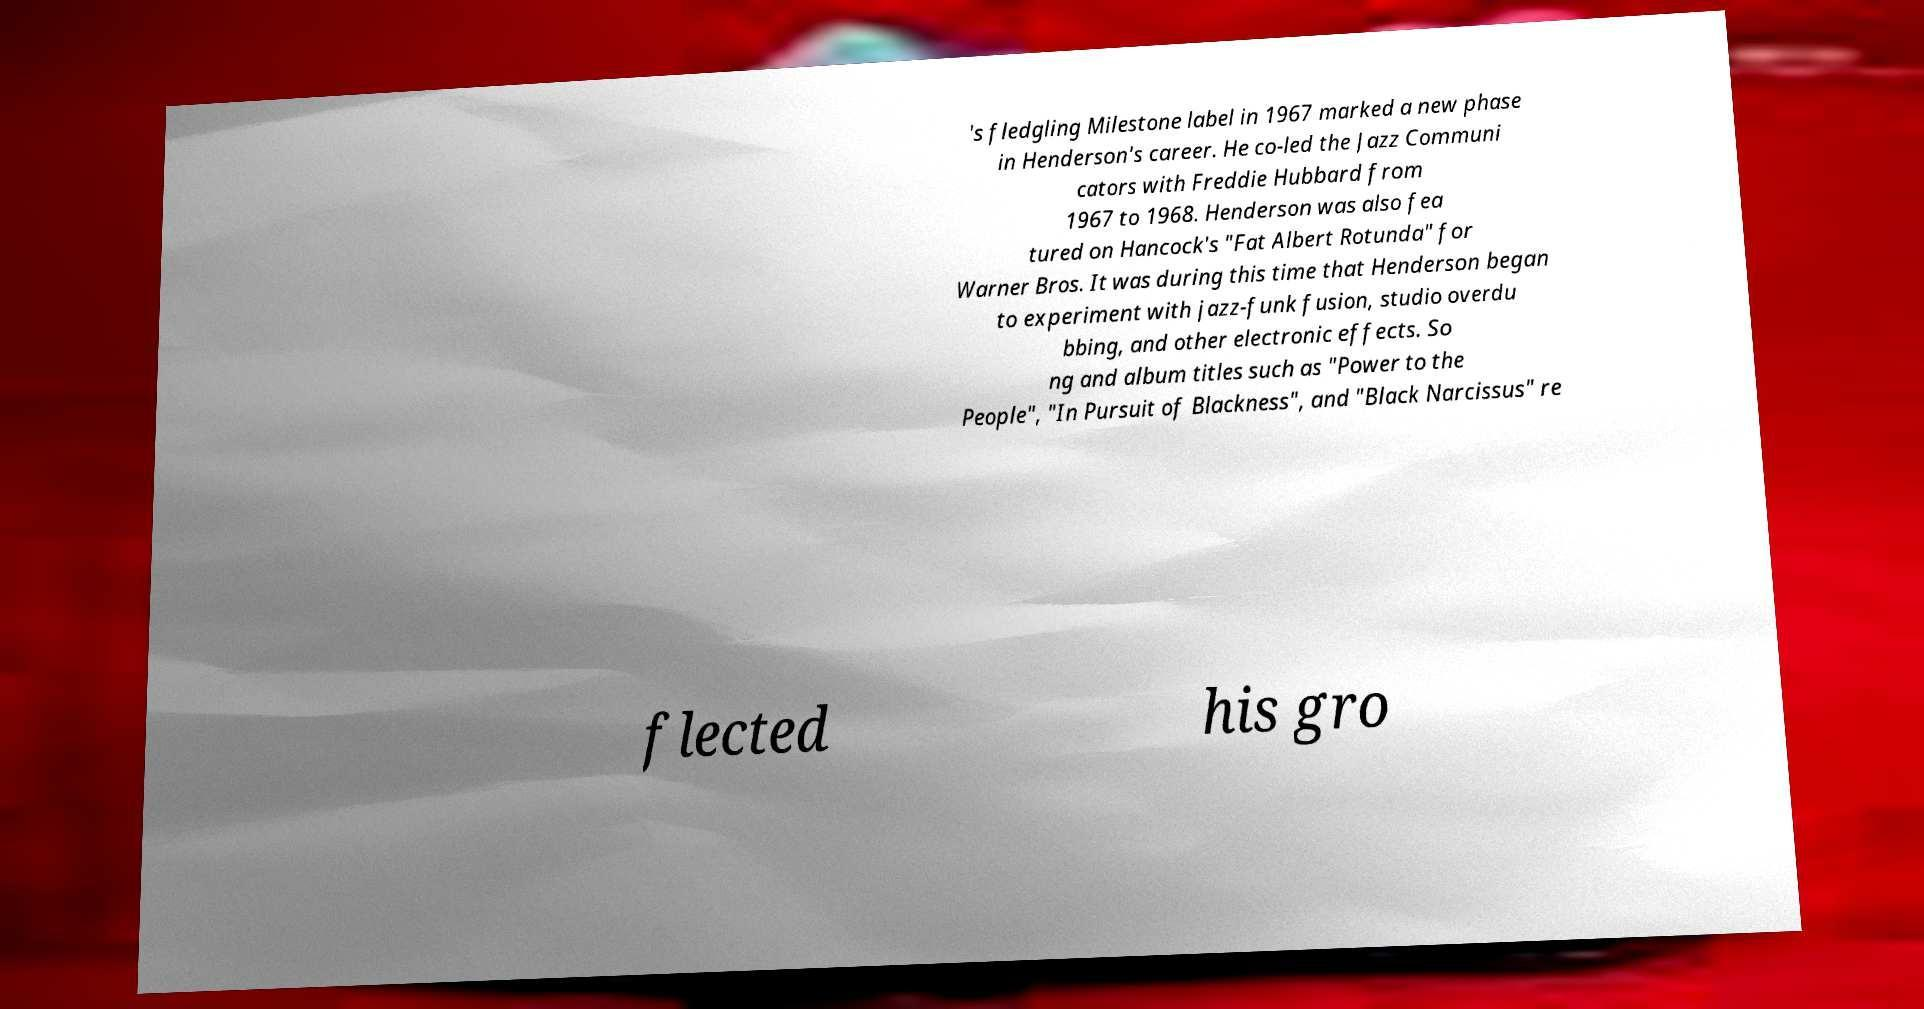What messages or text are displayed in this image? I need them in a readable, typed format. 's fledgling Milestone label in 1967 marked a new phase in Henderson's career. He co-led the Jazz Communi cators with Freddie Hubbard from 1967 to 1968. Henderson was also fea tured on Hancock's "Fat Albert Rotunda" for Warner Bros. It was during this time that Henderson began to experiment with jazz-funk fusion, studio overdu bbing, and other electronic effects. So ng and album titles such as "Power to the People", "In Pursuit of Blackness", and "Black Narcissus" re flected his gro 